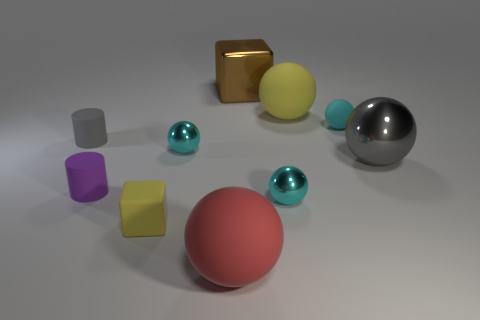Subtract all cyan cylinders. How many cyan balls are left? 3 Subtract all yellow spheres. How many spheres are left? 5 Subtract all tiny rubber balls. How many balls are left? 5 Subtract 2 spheres. How many spheres are left? 4 Subtract all gray spheres. Subtract all purple blocks. How many spheres are left? 5 Subtract all blocks. How many objects are left? 8 Subtract 0 gray cubes. How many objects are left? 10 Subtract all purple things. Subtract all tiny purple objects. How many objects are left? 8 Add 6 yellow things. How many yellow things are left? 8 Add 7 red objects. How many red objects exist? 8 